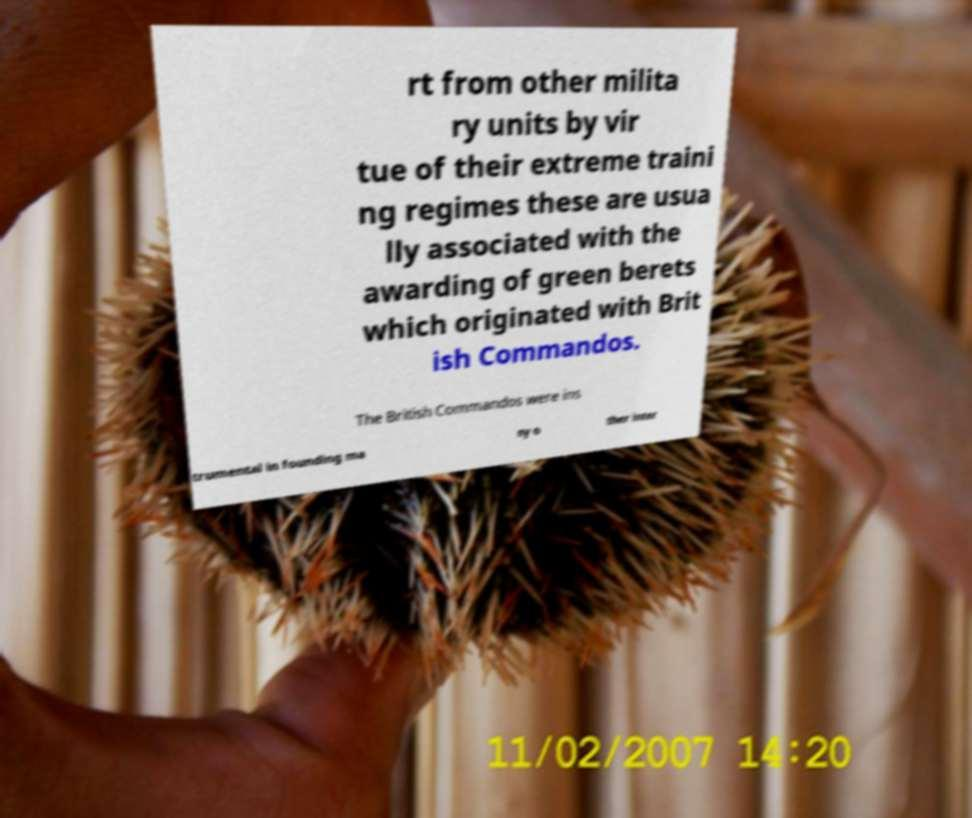For documentation purposes, I need the text within this image transcribed. Could you provide that? rt from other milita ry units by vir tue of their extreme traini ng regimes these are usua lly associated with the awarding of green berets which originated with Brit ish Commandos. The British Commandos were ins trumental in founding ma ny o ther inter 